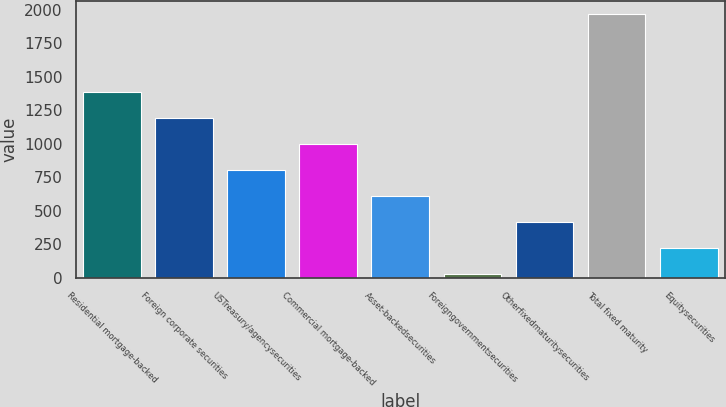Convert chart to OTSL. <chart><loc_0><loc_0><loc_500><loc_500><bar_chart><fcel>Residential mortgage-backed<fcel>Foreign corporate securities<fcel>USTreasury/agencysecurities<fcel>Commercial mortgage-backed<fcel>Asset-backedsecurities<fcel>Foreigngovernmentsecurities<fcel>Otherfixedmaturitysecurities<fcel>Total fixed maturity<fcel>Equitysecurities<nl><fcel>1386.2<fcel>1192.6<fcel>805.4<fcel>999<fcel>611.8<fcel>31<fcel>418.2<fcel>1967<fcel>224.6<nl></chart> 